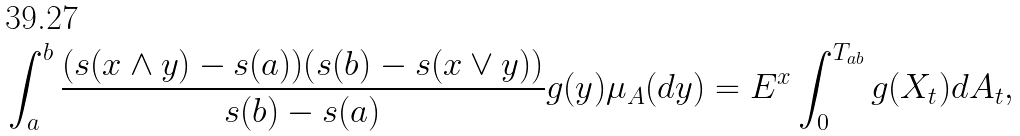Convert formula to latex. <formula><loc_0><loc_0><loc_500><loc_500>\int _ { a } ^ { b } \frac { ( s ( x \wedge y ) - s ( a ) ) ( s ( b ) - s ( x \vee y ) ) } { s ( b ) - s ( a ) } g ( y ) \mu _ { A } ( d y ) = E ^ { x } \int _ { 0 } ^ { T _ { a b } } g ( X _ { t } ) d A _ { t } ,</formula> 